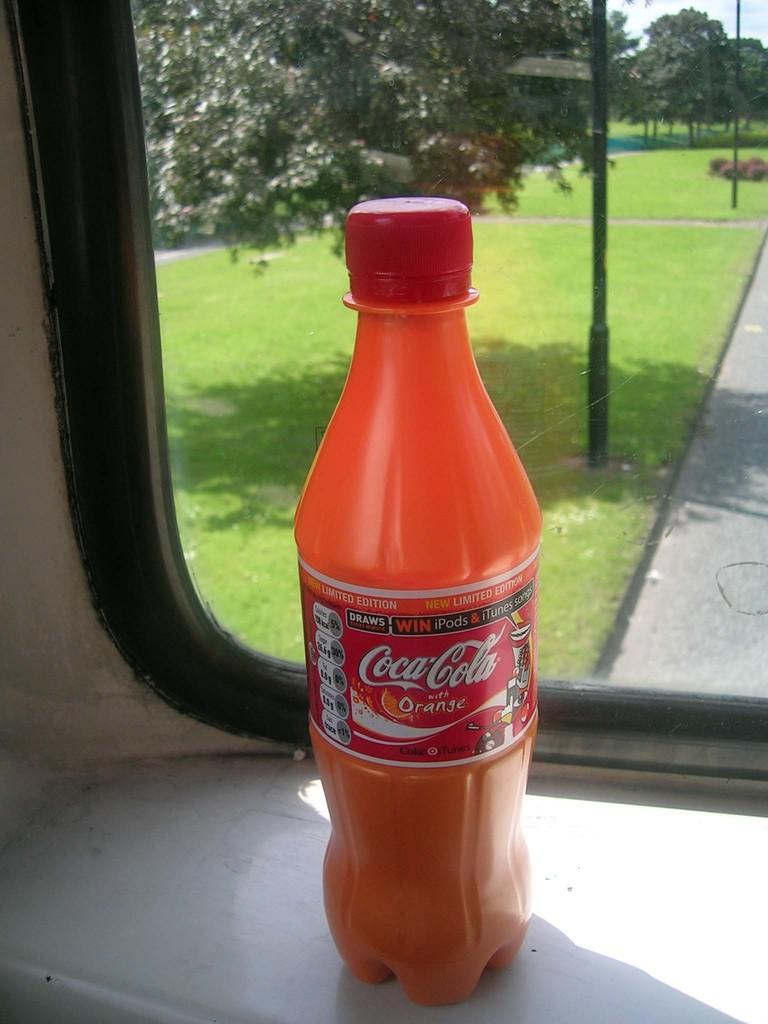<image>
Write a terse but informative summary of the picture. A bottle of Coca-Cola Orange in front of a window overlooking a grassy park 